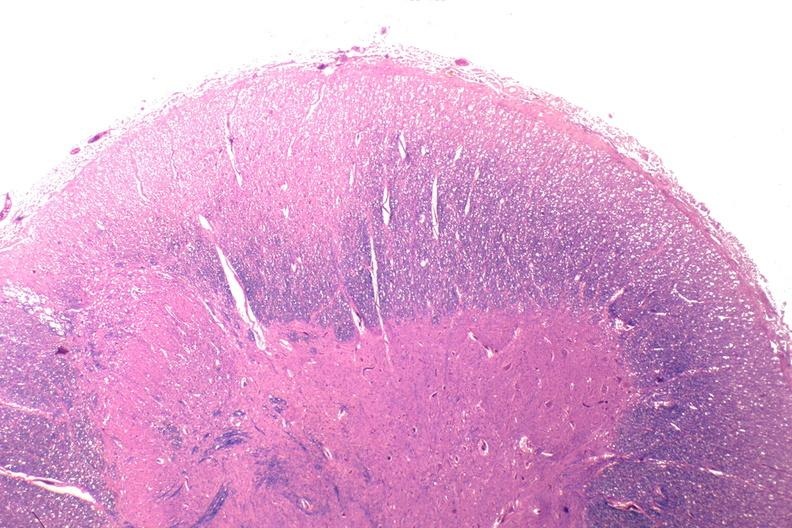s nervous present?
Answer the question using a single word or phrase. Yes 